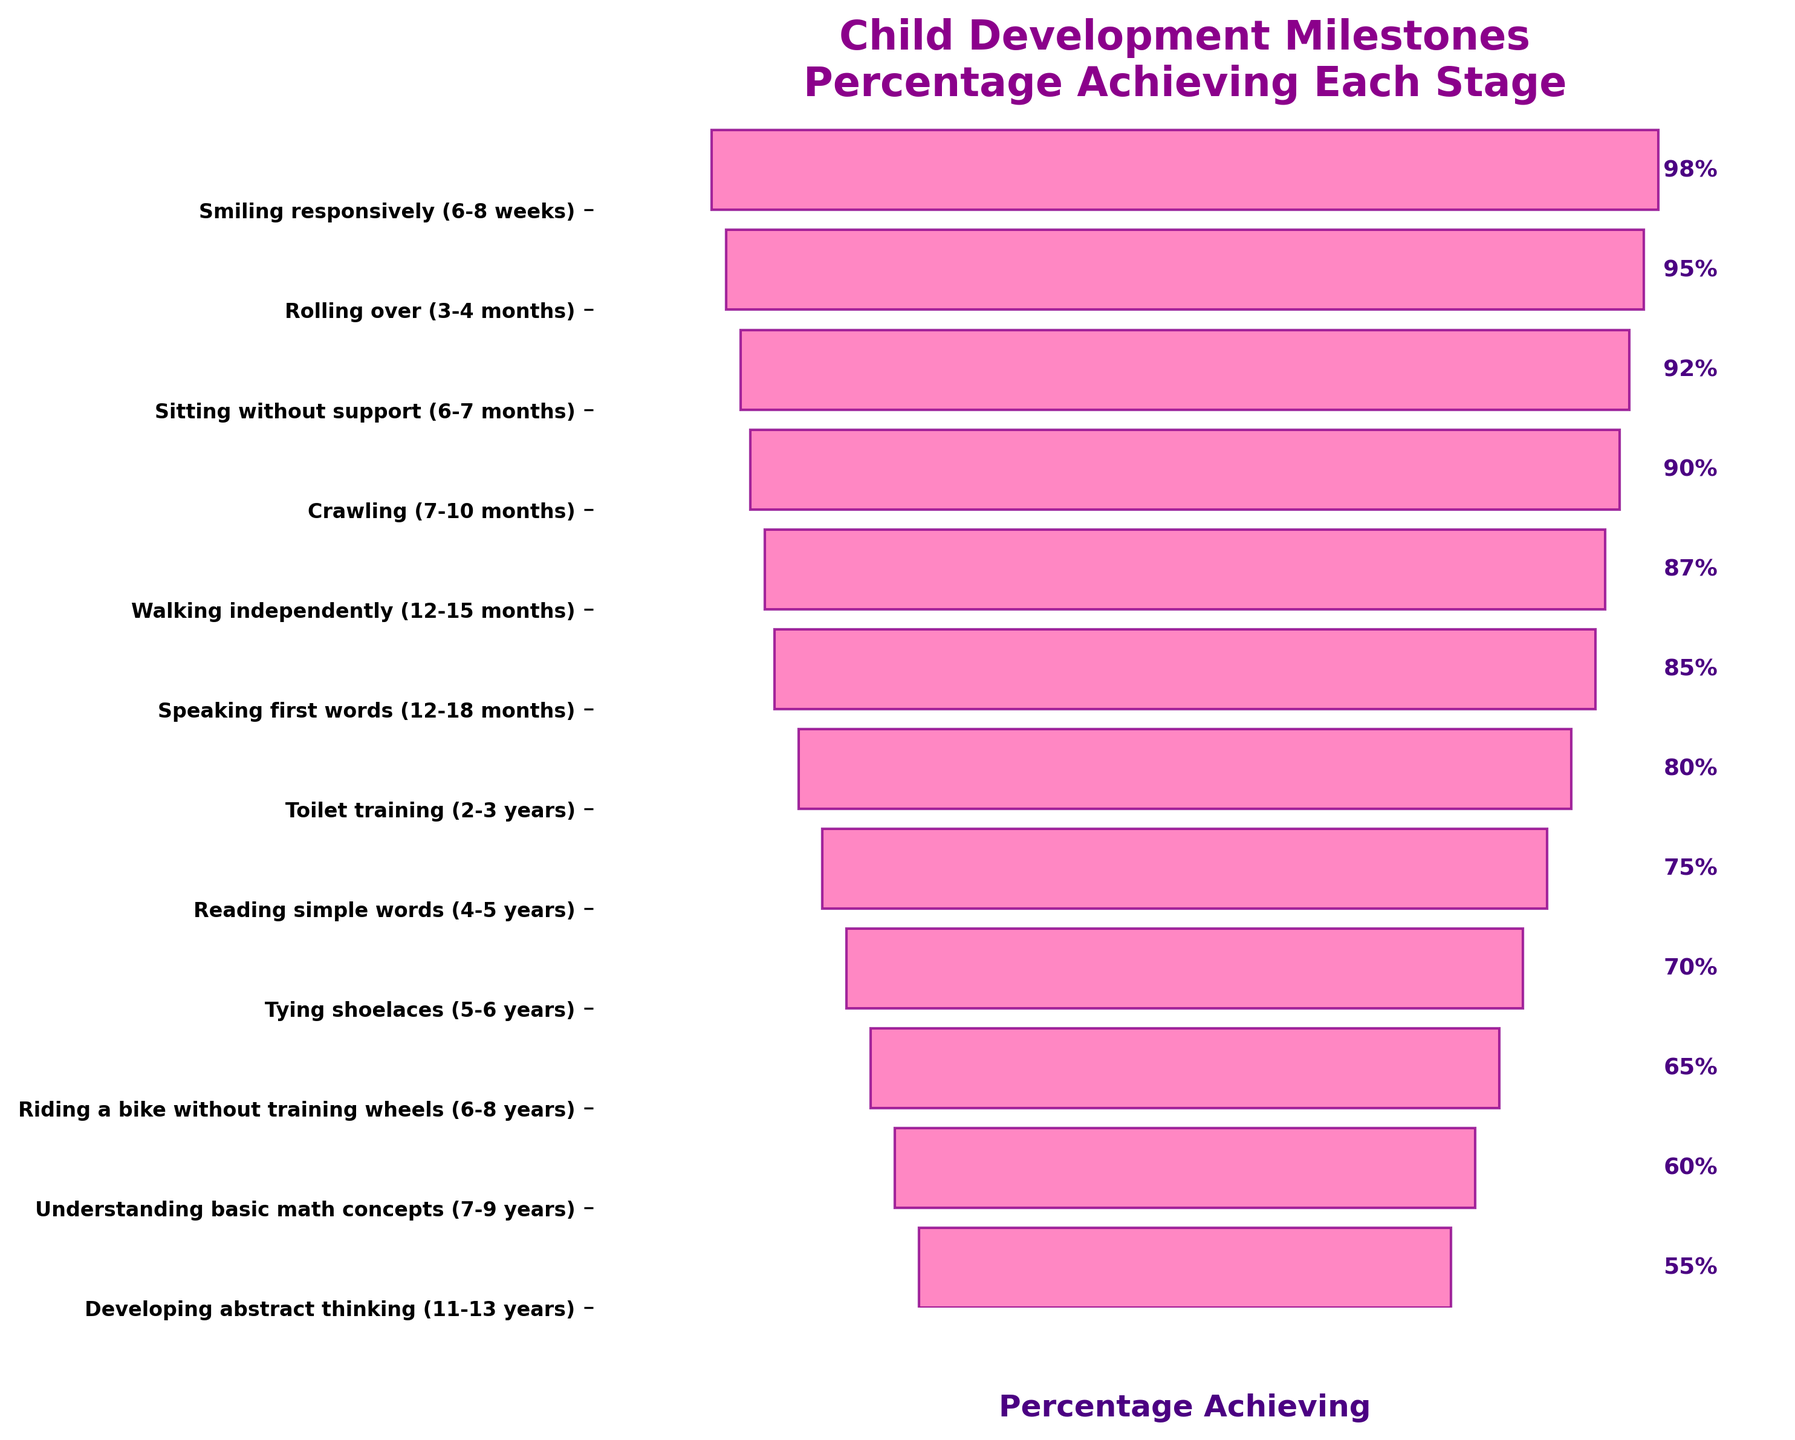What is the title of the figure? The title is usually located at the top center of the figure. It provides a brief description of what the figure is about.
Answer: Child Development Milestones\nPercentage Achieving Each Stage At what age do 85% of children speak their first words? Locate the milestone labeled "Speaking first words" in the y-axis labels, and then refer to the corresponding age range and percentage.
Answer: 12-18 months Which milestone has the highest percentage of achievement? Find the widest bar at the top of the funnel chart and read the corresponding milestone.
Answer: Smiling responsively (6-8 weeks) By how many percentage points does the achievement drop from "Sitting without support" to "Crawling"? Locate the percentages for both milestones and calculate the difference: 92% (Sitting without support) - 90% (Crawling).
Answer: 2 percentage points What is the smallest percentage for any milestone achieved? Look at the narrowest bar at the bottom of the funnel chart and read the corresponding percentage.
Answer: 55% How does the percentage change from "Tying shoelaces" to "Riding a bike without training wheels"? Identify and compare the percentages for both milestones: 70% (Tying shoelaces) to 65% (Riding a bike without training wheels). Determine the percentage drop.
Answer: 5 percentage points Which milestone shows a 10 percentage point drop from the previous stage? Compare the percentages of consecutive milestones to find the one that decreases by 10 points.
Answer: Understanding basic math concepts (7-9 years), which drops from 65% (Riding a bike without training wheels) Are more children able to "Toilet train" or "Read simple words"? Compare the percentages for both milestones indicated on the y-axis: 80% for "Toilet training" and 75% for "Reading simple words".
Answer: Toilet training Which milestones see less than 80% of children achieving them? Identify all milestones below the 80% mark on the funnel chart.
Answer: Reading simple words, Tying shoelaces, Riding a bike without training wheels, Understanding basic math concepts, Developing abstract thinking What percentage of children develop abstract thinking around ages 11-13? Locate the milestone labeled "Developing abstract thinking" and read the corresponding percentage on the bar.
Answer: 55% 